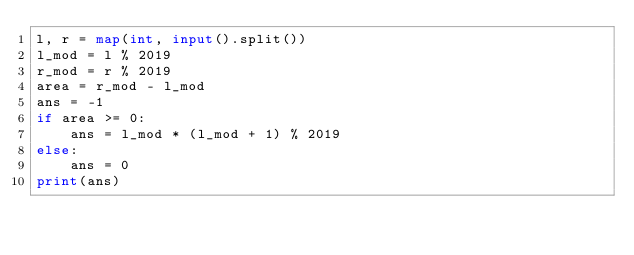Convert code to text. <code><loc_0><loc_0><loc_500><loc_500><_Python_>l, r = map(int, input().split())
l_mod = l % 2019
r_mod = r % 2019
area = r_mod - l_mod
ans = -1
if area >= 0:
    ans = l_mod * (l_mod + 1) % 2019
else:
    ans = 0
print(ans)
</code> 